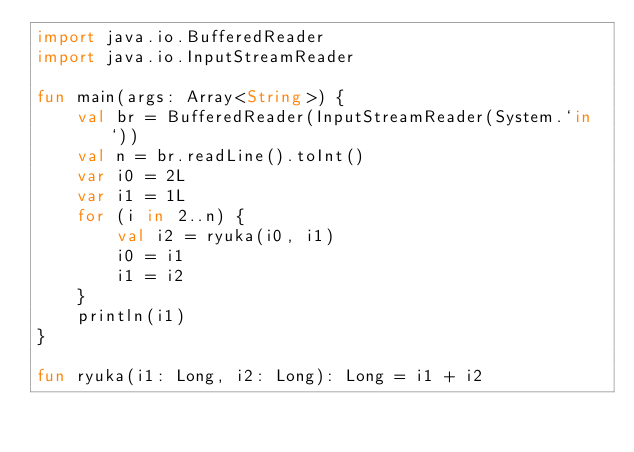Convert code to text. <code><loc_0><loc_0><loc_500><loc_500><_Kotlin_>import java.io.BufferedReader
import java.io.InputStreamReader

fun main(args: Array<String>) {
    val br = BufferedReader(InputStreamReader(System.`in`))
    val n = br.readLine().toInt()
    var i0 = 2L
    var i1 = 1L
    for (i in 2..n) {
        val i2 = ryuka(i0, i1)
        i0 = i1
        i1 = i2
    }
    println(i1)
}

fun ryuka(i1: Long, i2: Long): Long = i1 + i2</code> 